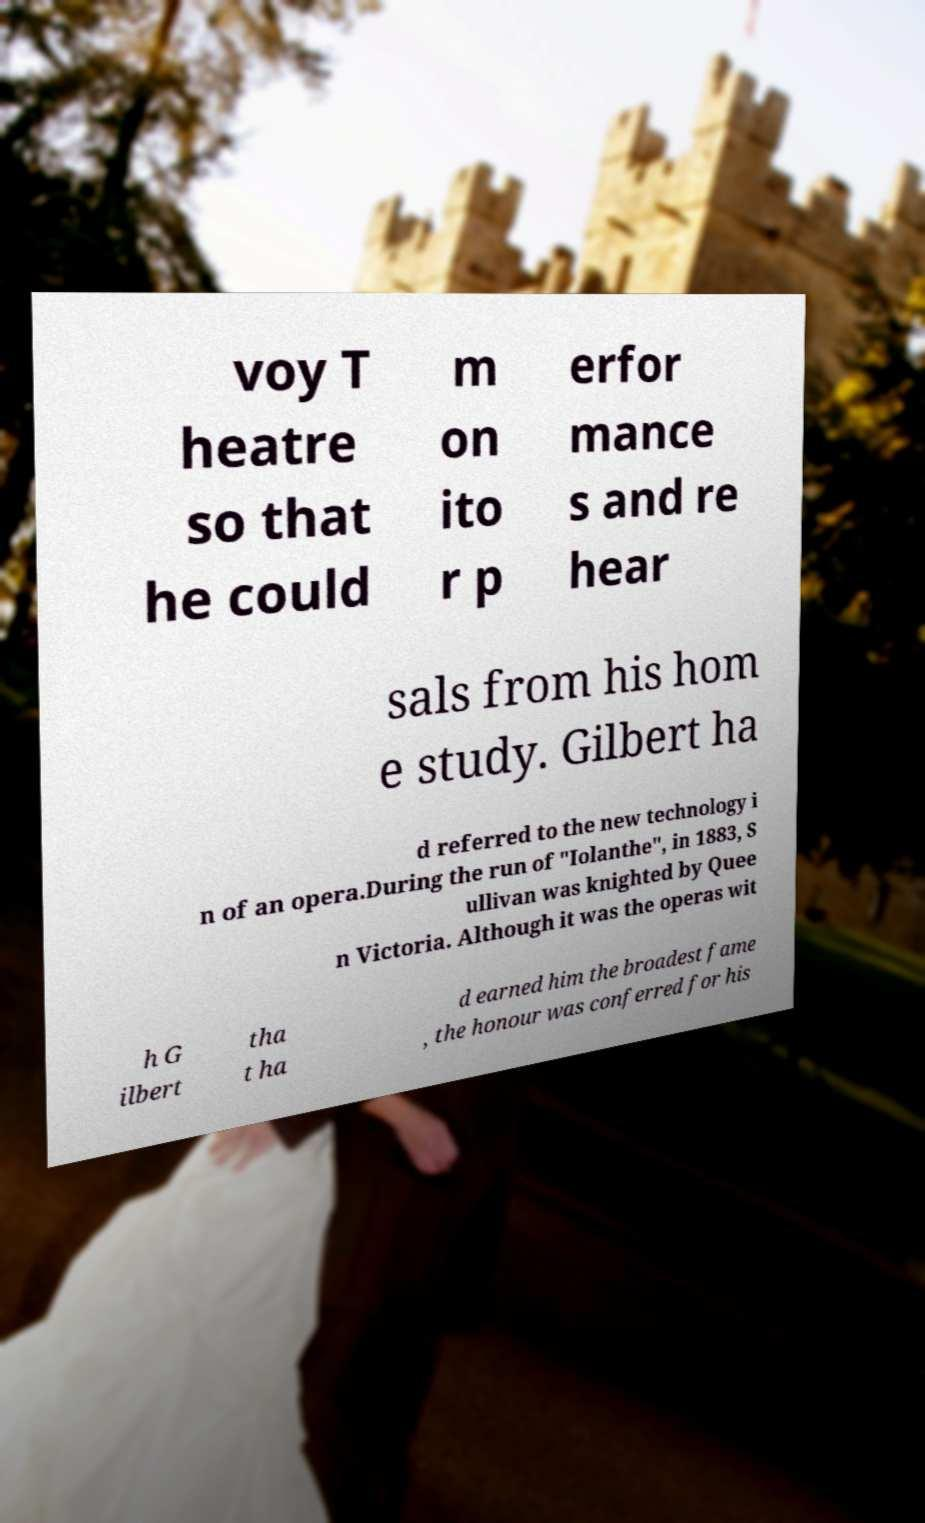Please read and relay the text visible in this image. What does it say? voy T heatre so that he could m on ito r p erfor mance s and re hear sals from his hom e study. Gilbert ha d referred to the new technology i n of an opera.During the run of "Iolanthe", in 1883, S ullivan was knighted by Quee n Victoria. Although it was the operas wit h G ilbert tha t ha d earned him the broadest fame , the honour was conferred for his 